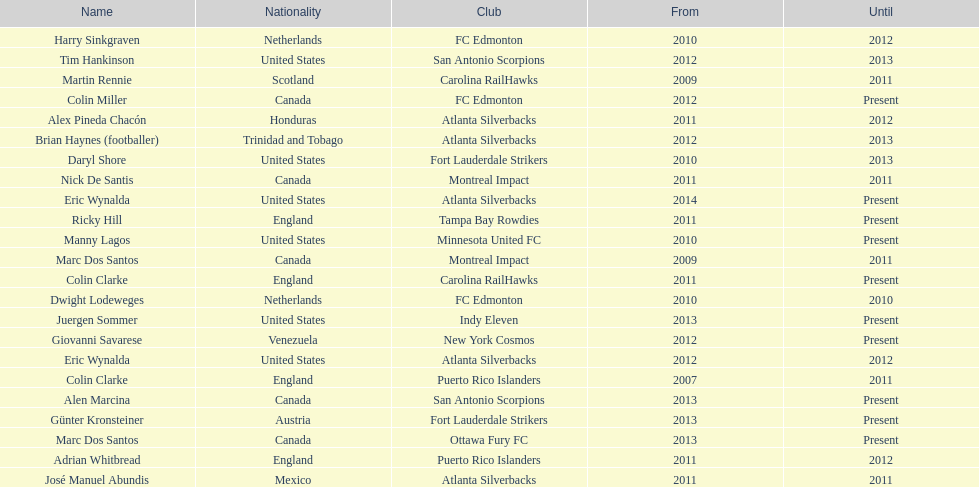Marc dos santos started as coach the same year as what other coach? Martin Rennie. Help me parse the entirety of this table. {'header': ['Name', 'Nationality', 'Club', 'From', 'Until'], 'rows': [['Harry Sinkgraven', 'Netherlands', 'FC Edmonton', '2010', '2012'], ['Tim Hankinson', 'United States', 'San Antonio Scorpions', '2012', '2013'], ['Martin Rennie', 'Scotland', 'Carolina RailHawks', '2009', '2011'], ['Colin Miller', 'Canada', 'FC Edmonton', '2012', 'Present'], ['Alex Pineda Chacón', 'Honduras', 'Atlanta Silverbacks', '2011', '2012'], ['Brian Haynes (footballer)', 'Trinidad and Tobago', 'Atlanta Silverbacks', '2012', '2013'], ['Daryl Shore', 'United States', 'Fort Lauderdale Strikers', '2010', '2013'], ['Nick De Santis', 'Canada', 'Montreal Impact', '2011', '2011'], ['Eric Wynalda', 'United States', 'Atlanta Silverbacks', '2014', 'Present'], ['Ricky Hill', 'England', 'Tampa Bay Rowdies', '2011', 'Present'], ['Manny Lagos', 'United States', 'Minnesota United FC', '2010', 'Present'], ['Marc Dos Santos', 'Canada', 'Montreal Impact', '2009', '2011'], ['Colin Clarke', 'England', 'Carolina RailHawks', '2011', 'Present'], ['Dwight Lodeweges', 'Netherlands', 'FC Edmonton', '2010', '2010'], ['Juergen Sommer', 'United States', 'Indy Eleven', '2013', 'Present'], ['Giovanni Savarese', 'Venezuela', 'New York Cosmos', '2012', 'Present'], ['Eric Wynalda', 'United States', 'Atlanta Silverbacks', '2012', '2012'], ['Colin Clarke', 'England', 'Puerto Rico Islanders', '2007', '2011'], ['Alen Marcina', 'Canada', 'San Antonio Scorpions', '2013', 'Present'], ['Günter Kronsteiner', 'Austria', 'Fort Lauderdale Strikers', '2013', 'Present'], ['Marc Dos Santos', 'Canada', 'Ottawa Fury FC', '2013', 'Present'], ['Adrian Whitbread', 'England', 'Puerto Rico Islanders', '2011', '2012'], ['José Manuel Abundis', 'Mexico', 'Atlanta Silverbacks', '2011', '2011']]} 